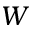<formula> <loc_0><loc_0><loc_500><loc_500>W</formula> 